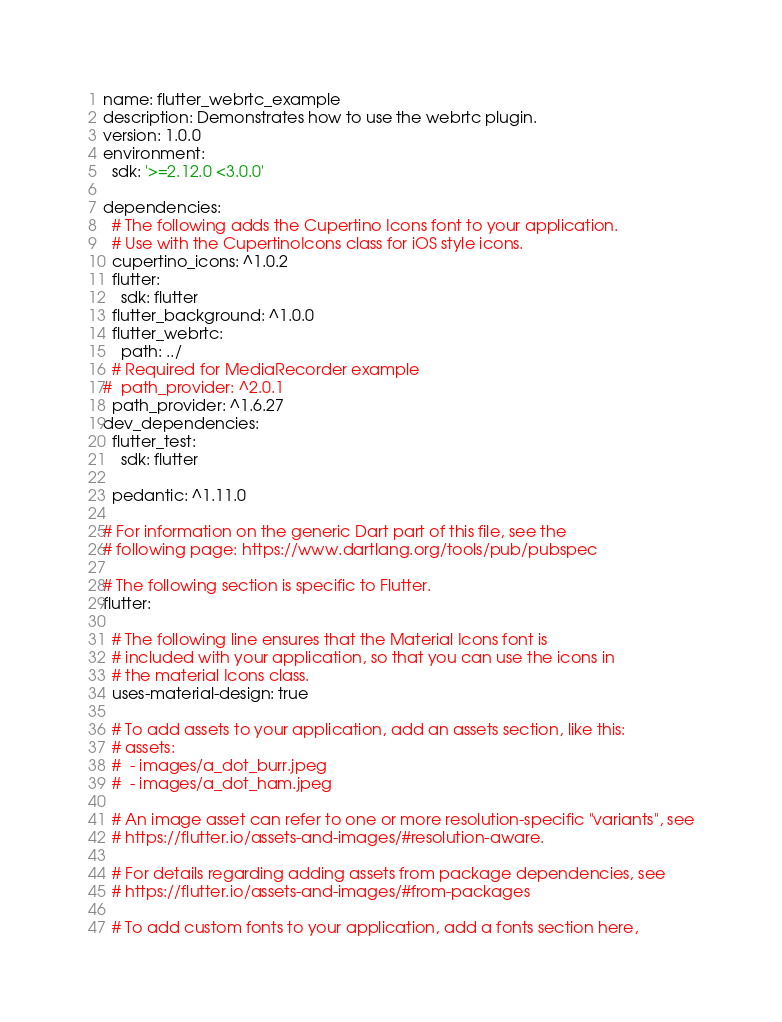<code> <loc_0><loc_0><loc_500><loc_500><_YAML_>name: flutter_webrtc_example
description: Demonstrates how to use the webrtc plugin.
version: 1.0.0
environment:
  sdk: '>=2.12.0 <3.0.0'
  
dependencies:
  # The following adds the Cupertino Icons font to your application.
  # Use with the CupertinoIcons class for iOS style icons.
  cupertino_icons: ^1.0.2
  flutter:
    sdk: flutter
  flutter_background: ^1.0.0
  flutter_webrtc:
    path: ../
  # Required for MediaRecorder example
#  path_provider: ^2.0.1
  path_provider: ^1.6.27
dev_dependencies:
  flutter_test:
    sdk: flutter

  pedantic: ^1.11.0

# For information on the generic Dart part of this file, see the
# following page: https://www.dartlang.org/tools/pub/pubspec

# The following section is specific to Flutter.
flutter:

  # The following line ensures that the Material Icons font is
  # included with your application, so that you can use the icons in
  # the material Icons class.
  uses-material-design: true

  # To add assets to your application, add an assets section, like this:
  # assets:
  #  - images/a_dot_burr.jpeg
  #  - images/a_dot_ham.jpeg

  # An image asset can refer to one or more resolution-specific "variants", see
  # https://flutter.io/assets-and-images/#resolution-aware.

  # For details regarding adding assets from package dependencies, see
  # https://flutter.io/assets-and-images/#from-packages

  # To add custom fonts to your application, add a fonts section here,</code> 